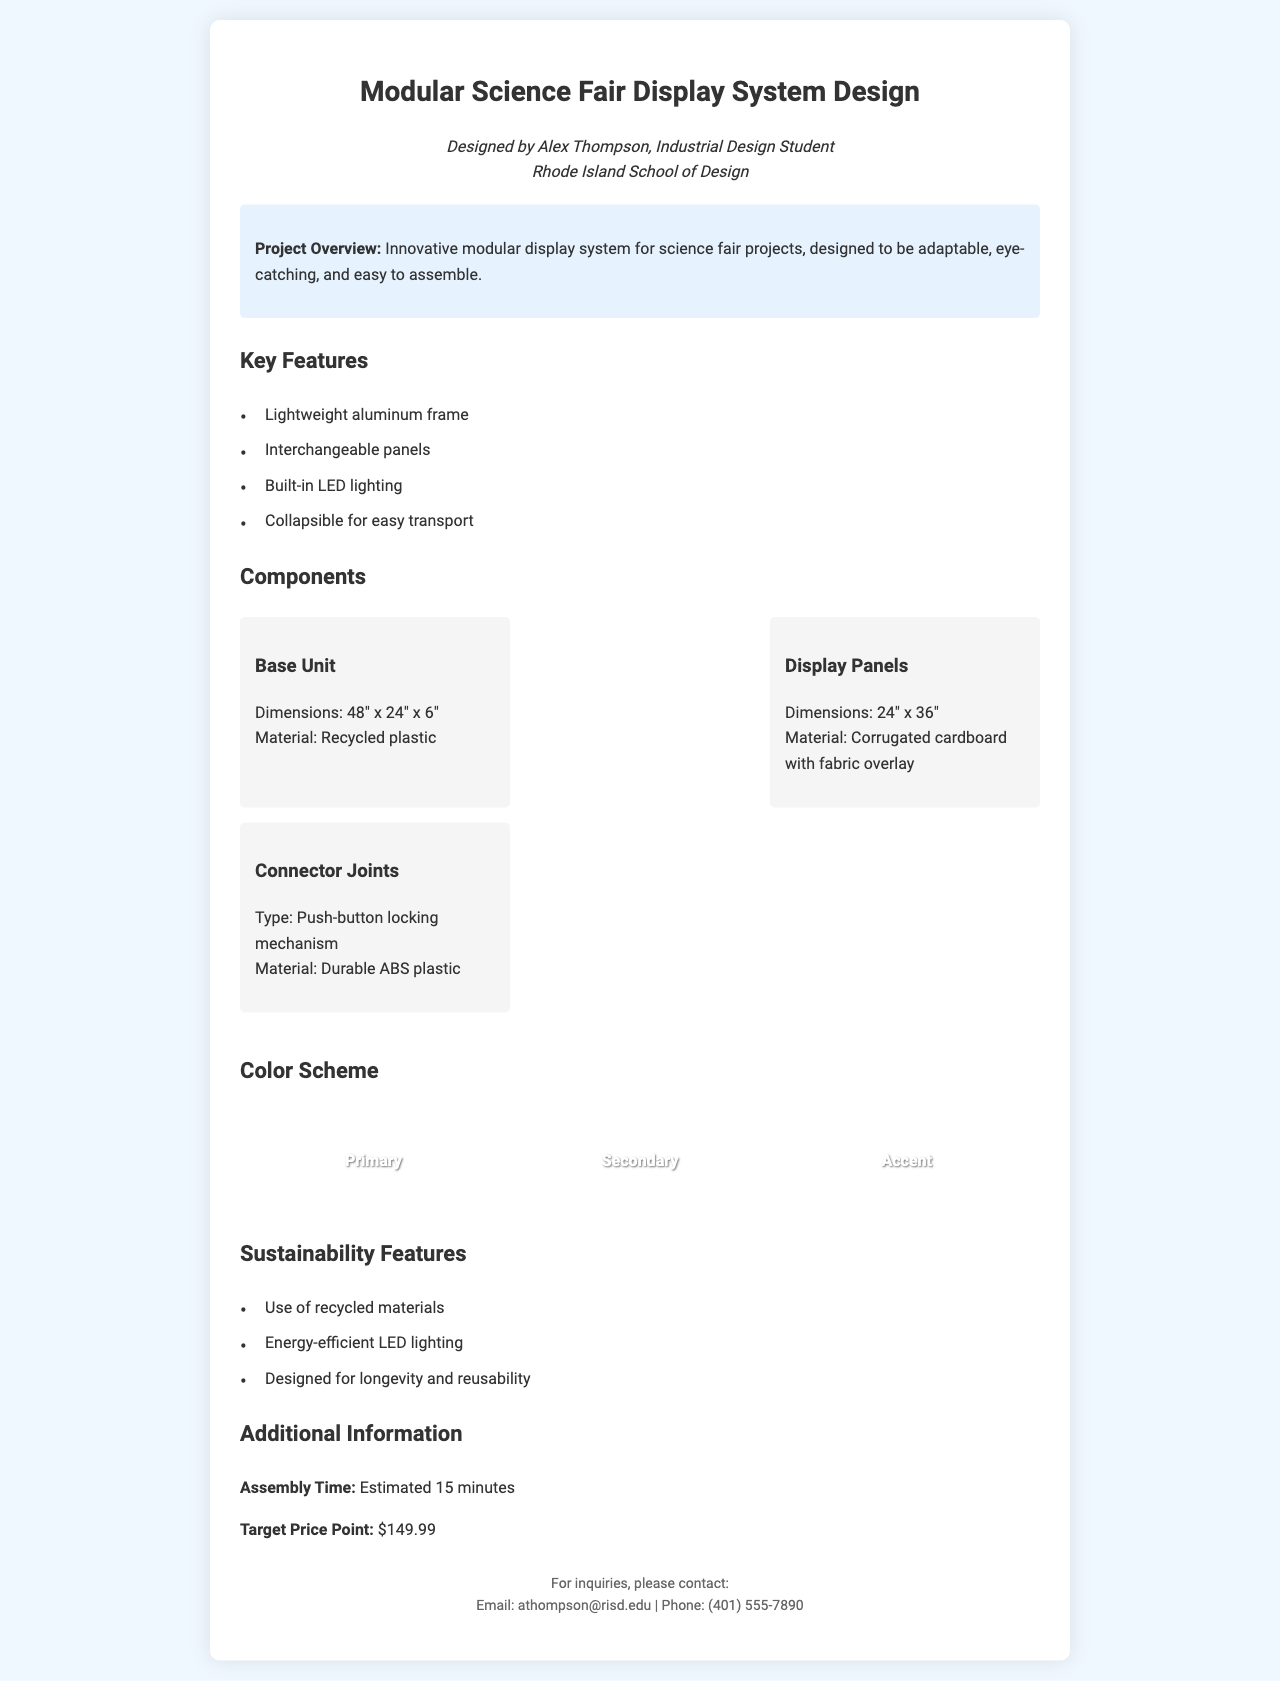what is the designer's name? The designer's name is mentioned in the designer info section of the document.
Answer: Alex Thompson what are the dimensions of the base unit? The dimensions of the base unit are specified in the components section of the document.
Answer: 48" x 24" x 6" what is the target price point? The target price point is provided in the additional information section of the document.
Answer: $149.99 how long is the estimated assembly time? The estimated assembly time is mentioned in the additional information section of the document.
Answer: 15 minutes what material is used for the display panels? The material for the display panels is listed in the components section of the document.
Answer: Corrugated cardboard with fabric overlay how many sustainability features are listed? The document lists specific sustainability features in the sustainability features section.
Answer: Three what type of locking mechanism is used for connector joints? The type of locking mechanism is detailed in the components section of the document.
Answer: Push-button locking mechanism what is the primary color in the color scheme? The primary color is identified in the color scheme section of the document.
Answer: Primary which institution is the designer affiliated with? The designer's institution is mentioned in the designer info section of the document.
Answer: Rhode Island School of Design 